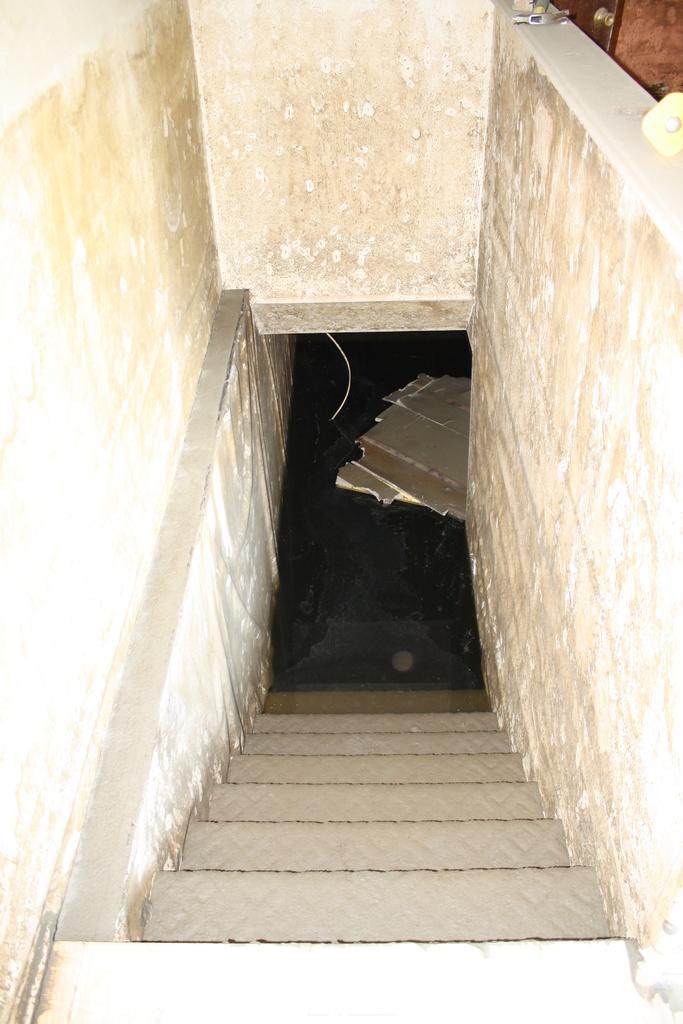Describe this image in one or two sentences. In the foreground of this image, there are stairs and on either side there is wall. We can also see few wooden plank like objects. 